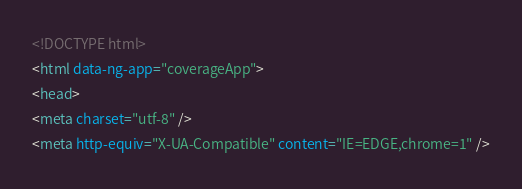Convert code to text. <code><loc_0><loc_0><loc_500><loc_500><_HTML_><!DOCTYPE html>
<html data-ng-app="coverageApp">
<head>
<meta charset="utf-8" />
<meta http-equiv="X-UA-Compatible" content="IE=EDGE,chrome=1" /></code> 